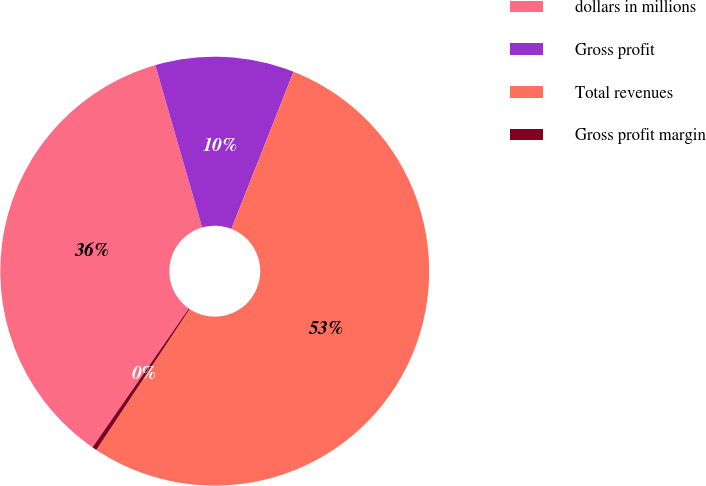Convert chart. <chart><loc_0><loc_0><loc_500><loc_500><pie_chart><fcel>dollars in millions<fcel>Gross profit<fcel>Total revenues<fcel>Gross profit margin<nl><fcel>35.87%<fcel>10.46%<fcel>53.32%<fcel>0.35%<nl></chart> 